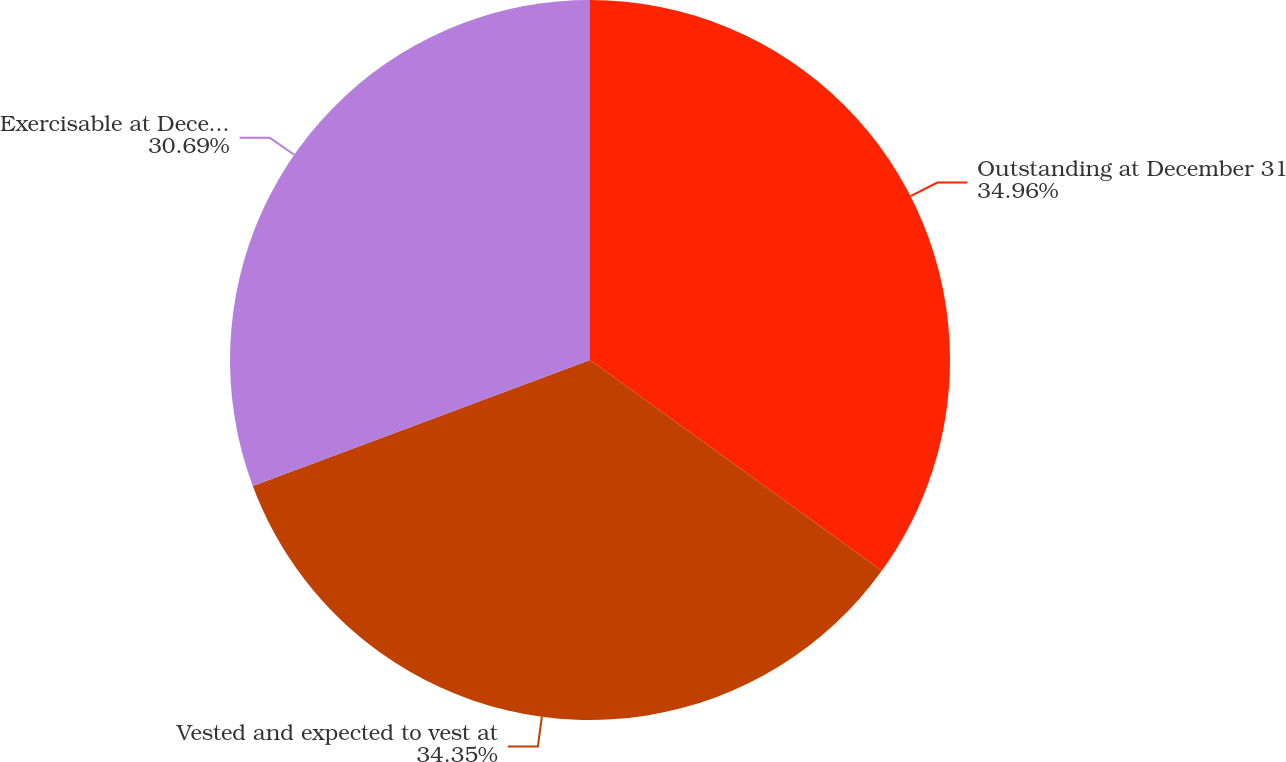Convert chart to OTSL. <chart><loc_0><loc_0><loc_500><loc_500><pie_chart><fcel>Outstanding at December 31<fcel>Vested and expected to vest at<fcel>Exercisable at December 31<nl><fcel>34.96%<fcel>34.35%<fcel>30.69%<nl></chart> 